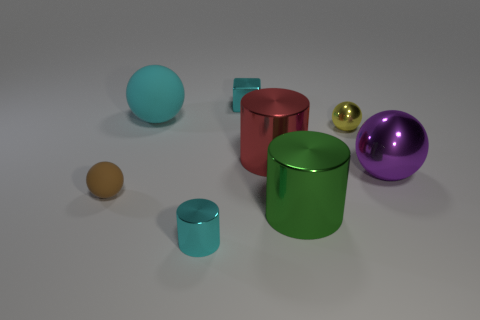Can you describe the arrangement of the objects? Certainly! The objects are spaced out on a flat surface, almost creating a diagonal line from the bottom left to the top right corner of the image. They feature a variety of colors and reflectivity, including matte and shiny surfaces, and consist of spheres and cylinders. 